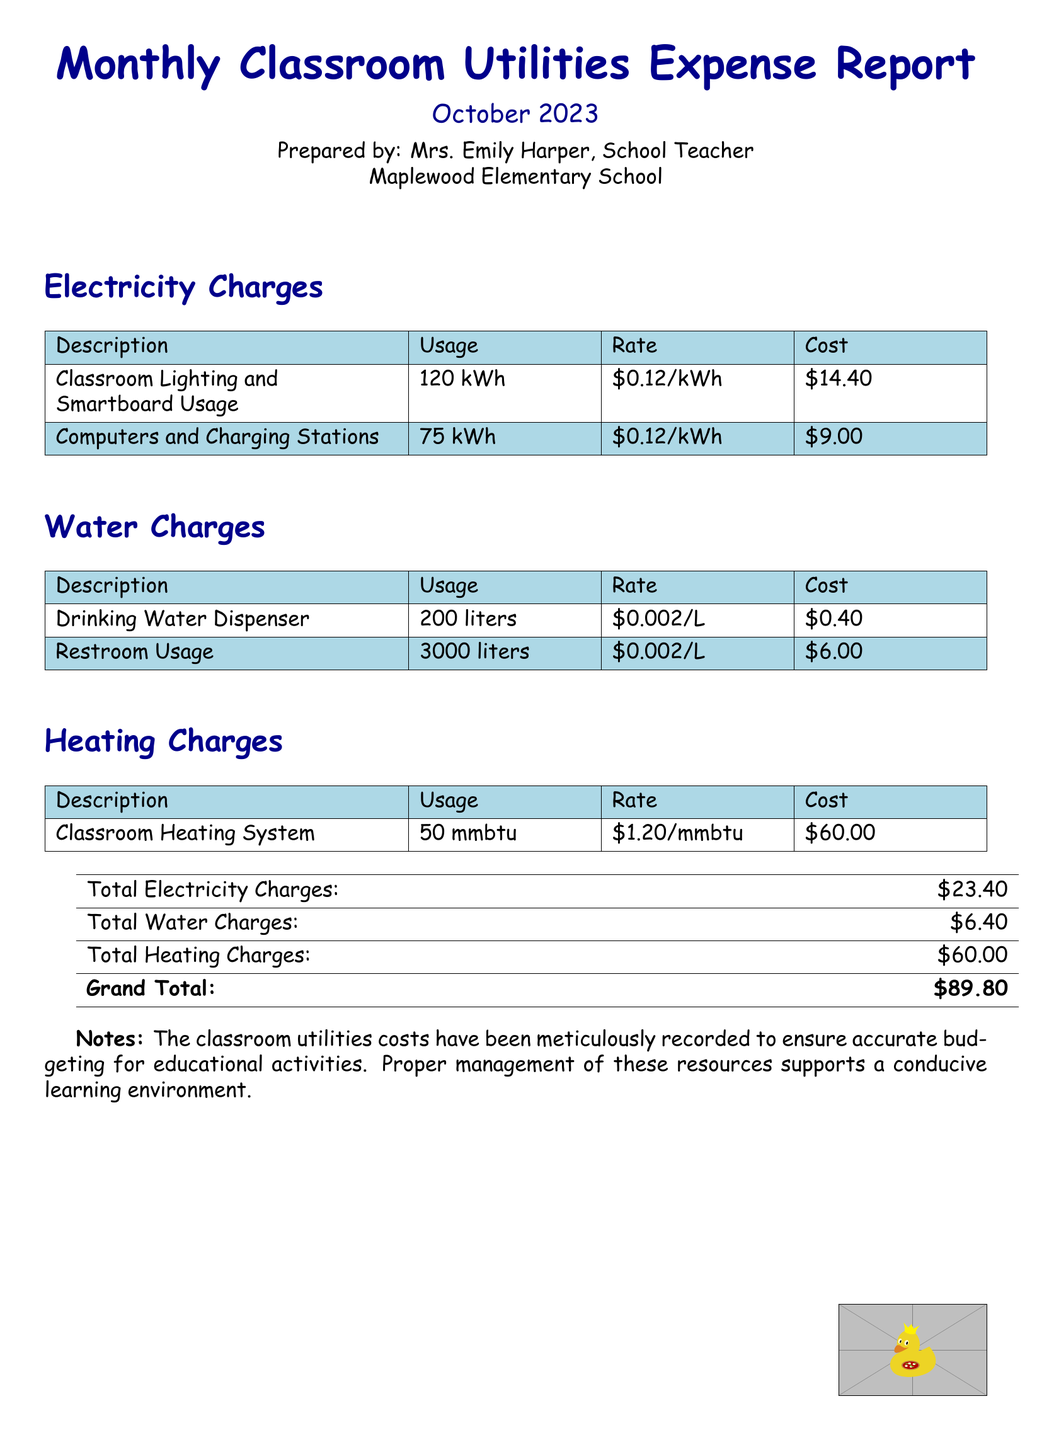What are the total electricity charges? The total electricity charges are stated in the summary section of the document.
Answer: $23.40 What is the rate for restroom water usage? The rate for restroom usage can be found in the water charges section of the document.
Answer: $0.002/L How much was spent on classroom heating? The heating charges section lists the cost associated with the classroom heating system.
Answer: $60.00 What was the usage of drinking water? The document specifies the usage of drinking water in the water charges section.
Answer: 200 liters Who prepared the report? The preparer's name is mentioned at the beginning of the document.
Answer: Mrs. Emily Harper What is the grand total for classroom utilities? The grand total is provided in the final summary table of the report.
Answer: $89.80 What is the usage of classroom lighting and smartboard? The usage for classroom lighting and smartboard is indicated in the electricity charges section.
Answer: 120 kWh What type of report is this? The document clearly states the type of report at the top.
Answer: Expense Report What is the rate for classroom heating system? The cost per unit for heating is stated in the heating charges section.
Answer: $1.20/mmbtu 